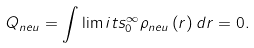<formula> <loc_0><loc_0><loc_500><loc_500>Q _ { n e u } = \int \lim i t s _ { 0 } ^ { \infty } { \rho _ { n e u } } \left ( r \right ) d r = 0 .</formula> 